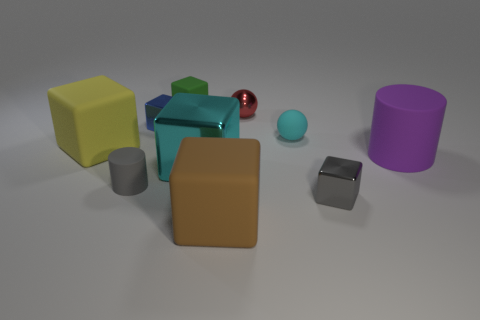What is the color of the large cylinder?
Offer a very short reply. Purple. There is a tiny metallic cube behind the small matte ball; how many purple matte cylinders are right of it?
Ensure brevity in your answer.  1. There is a blue metallic object; is it the same size as the matte cylinder that is in front of the big cyan cube?
Give a very brief answer. Yes. Do the blue metallic block and the cyan rubber object have the same size?
Make the answer very short. Yes. Is there a matte thing of the same size as the cyan ball?
Make the answer very short. Yes. What material is the cylinder to the left of the large brown object?
Give a very brief answer. Rubber. What color is the large cylinder that is the same material as the tiny green thing?
Offer a terse response. Purple. How many metallic things are yellow cubes or gray things?
Offer a very short reply. 1. What is the shape of the gray matte thing that is the same size as the matte sphere?
Your answer should be compact. Cylinder. How many objects are big rubber things that are to the right of the small red metal sphere or cubes that are behind the tiny cyan thing?
Offer a very short reply. 3. 